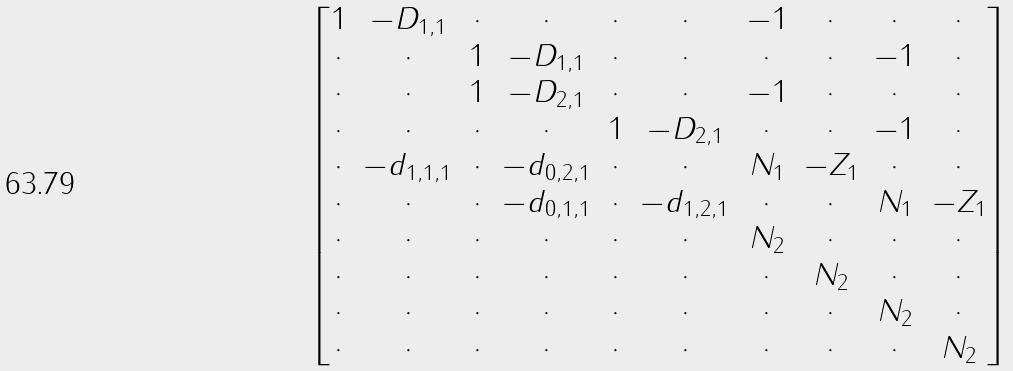Convert formula to latex. <formula><loc_0><loc_0><loc_500><loc_500>\begin{bmatrix} 1 & - D _ { 1 , 1 } & \cdot & \cdot & \cdot & \cdot & - 1 & \cdot & \cdot & \cdot \\ \cdot & \cdot & 1 & - D _ { 1 , 1 } & \cdot & \cdot & \cdot & \cdot & - 1 & \cdot \\ \cdot & \cdot & 1 & - D _ { 2 , 1 } & \cdot & \cdot & - 1 & \cdot & \cdot & \cdot \\ \cdot & \cdot & \cdot & \cdot & 1 & - D _ { 2 , 1 } & \cdot & \cdot & - 1 & \cdot \\ \cdot & - d _ { 1 , 1 , 1 } & \cdot & - d _ { 0 , 2 , 1 } & \cdot & \cdot & N _ { 1 } & - Z _ { 1 } & \cdot & \cdot \\ \cdot & \cdot & \cdot & - d _ { 0 , 1 , 1 } & \cdot & - d _ { 1 , 2 , 1 } & \cdot & \cdot & N _ { 1 } & - Z _ { 1 } \\ \cdot & \cdot & \cdot & \cdot & \cdot & \cdot & N _ { 2 } & \cdot & \cdot & \cdot \\ \cdot & \cdot & \cdot & \cdot & \cdot & \cdot & \cdot & N _ { 2 } & \cdot & \cdot \\ \cdot & \cdot & \cdot & \cdot & \cdot & \cdot & \cdot & \cdot & N _ { 2 } & \cdot \\ \cdot & \cdot & \cdot & \cdot & \cdot & \cdot & \cdot & \cdot & \cdot & N _ { 2 } \\ \end{bmatrix}</formula> 